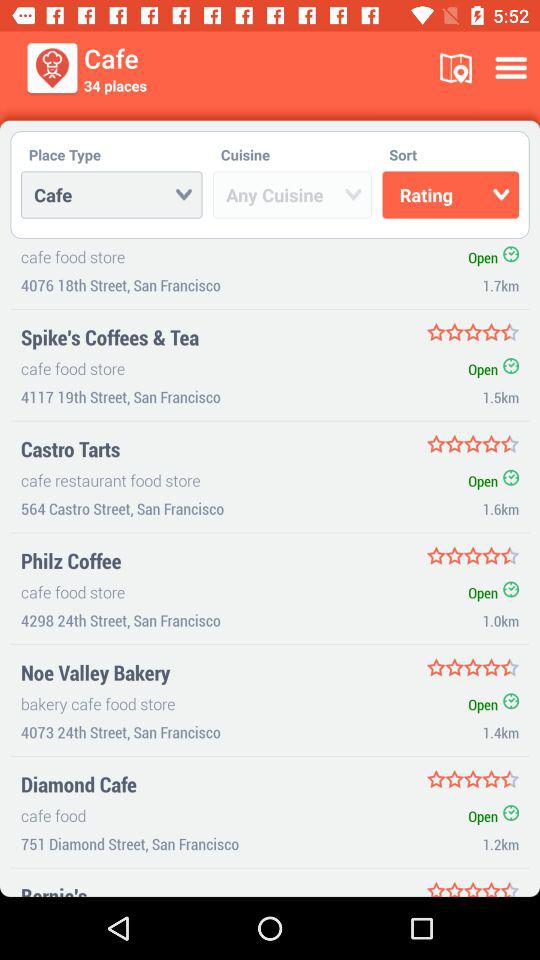What is the address of "Castro Tarts"? The address of "Castro Tarts" is 564 Castro Street, San Francisco. 